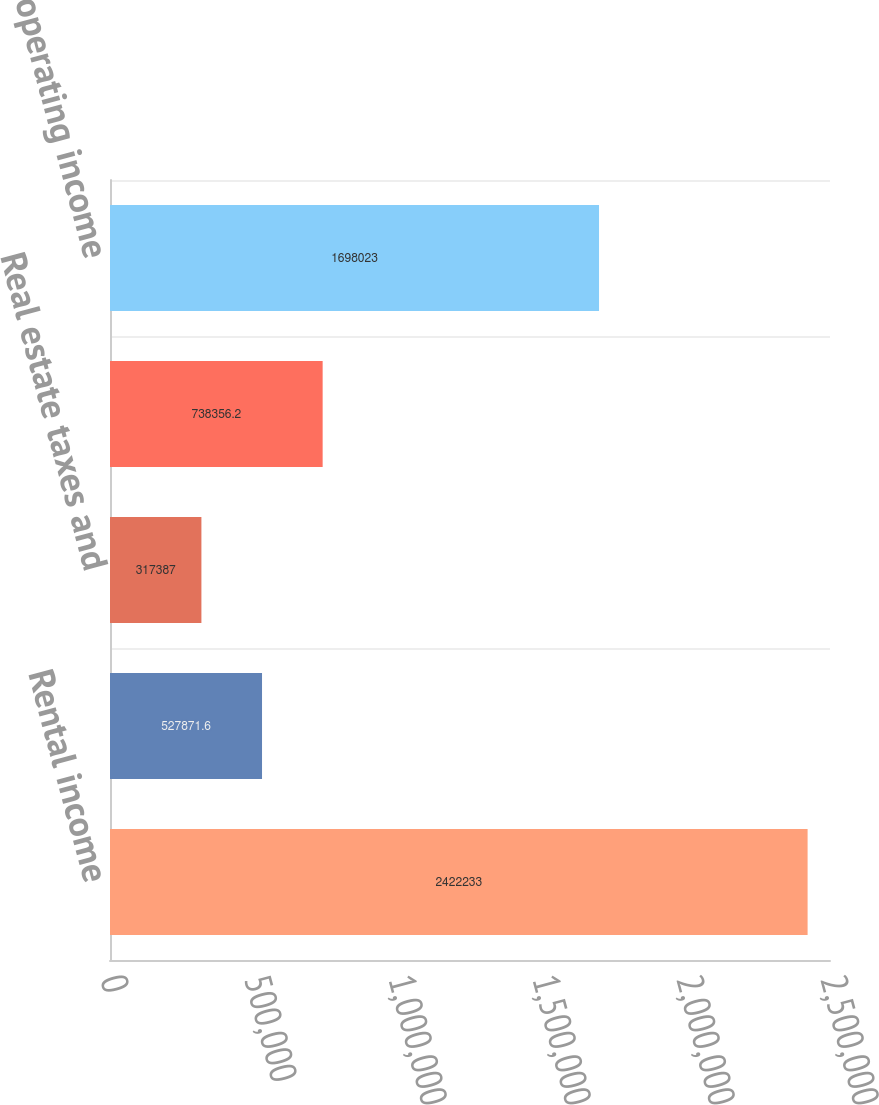Convert chart to OTSL. <chart><loc_0><loc_0><loc_500><loc_500><bar_chart><fcel>Rental income<fcel>Property and maintenance<fcel>Real estate taxes and<fcel>Total operating expenses<fcel>Net operating income<nl><fcel>2.42223e+06<fcel>527872<fcel>317387<fcel>738356<fcel>1.69802e+06<nl></chart> 